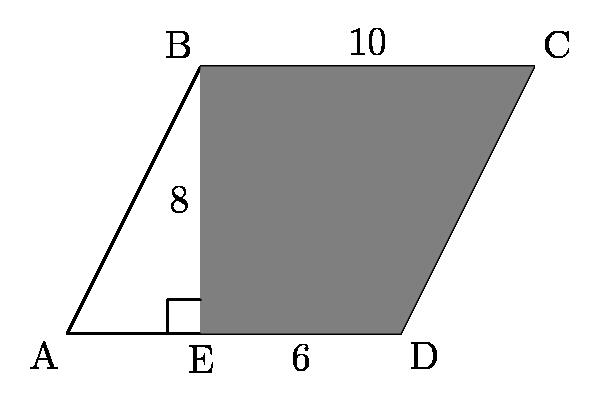The area of the shaded region $\text{BEDC}$ in parallelogram $\text{ABCD}$ is

 Answer is 64. 